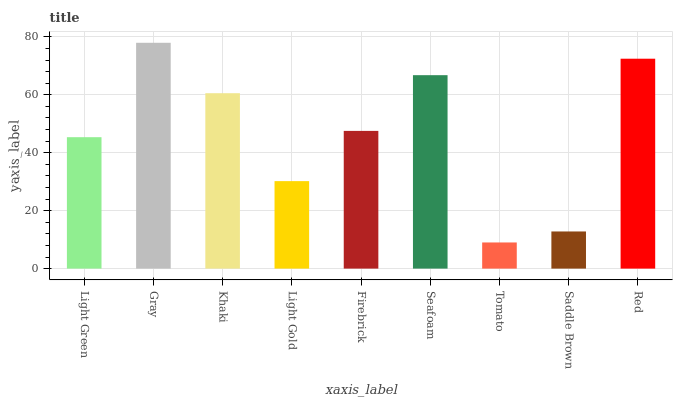Is Tomato the minimum?
Answer yes or no. Yes. Is Gray the maximum?
Answer yes or no. Yes. Is Khaki the minimum?
Answer yes or no. No. Is Khaki the maximum?
Answer yes or no. No. Is Gray greater than Khaki?
Answer yes or no. Yes. Is Khaki less than Gray?
Answer yes or no. Yes. Is Khaki greater than Gray?
Answer yes or no. No. Is Gray less than Khaki?
Answer yes or no. No. Is Firebrick the high median?
Answer yes or no. Yes. Is Firebrick the low median?
Answer yes or no. Yes. Is Tomato the high median?
Answer yes or no. No. Is Gray the low median?
Answer yes or no. No. 